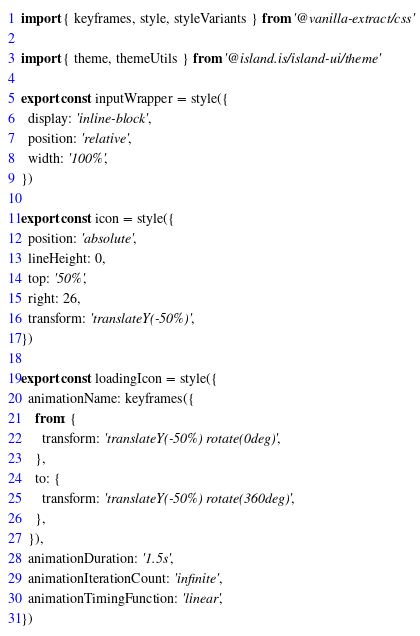Convert code to text. <code><loc_0><loc_0><loc_500><loc_500><_TypeScript_>import { keyframes, style, styleVariants } from '@vanilla-extract/css'

import { theme, themeUtils } from '@island.is/island-ui/theme'

export const inputWrapper = style({
  display: 'inline-block',
  position: 'relative',
  width: '100%',
})

export const icon = style({
  position: 'absolute',
  lineHeight: 0,
  top: '50%',
  right: 26,
  transform: 'translateY(-50%)',
})

export const loadingIcon = style({
  animationName: keyframes({
    from: {
      transform: 'translateY(-50%) rotate(0deg)',
    },
    to: {
      transform: 'translateY(-50%) rotate(360deg)',
    },
  }),
  animationDuration: '1.5s',
  animationIterationCount: 'infinite',
  animationTimingFunction: 'linear',
})
</code> 